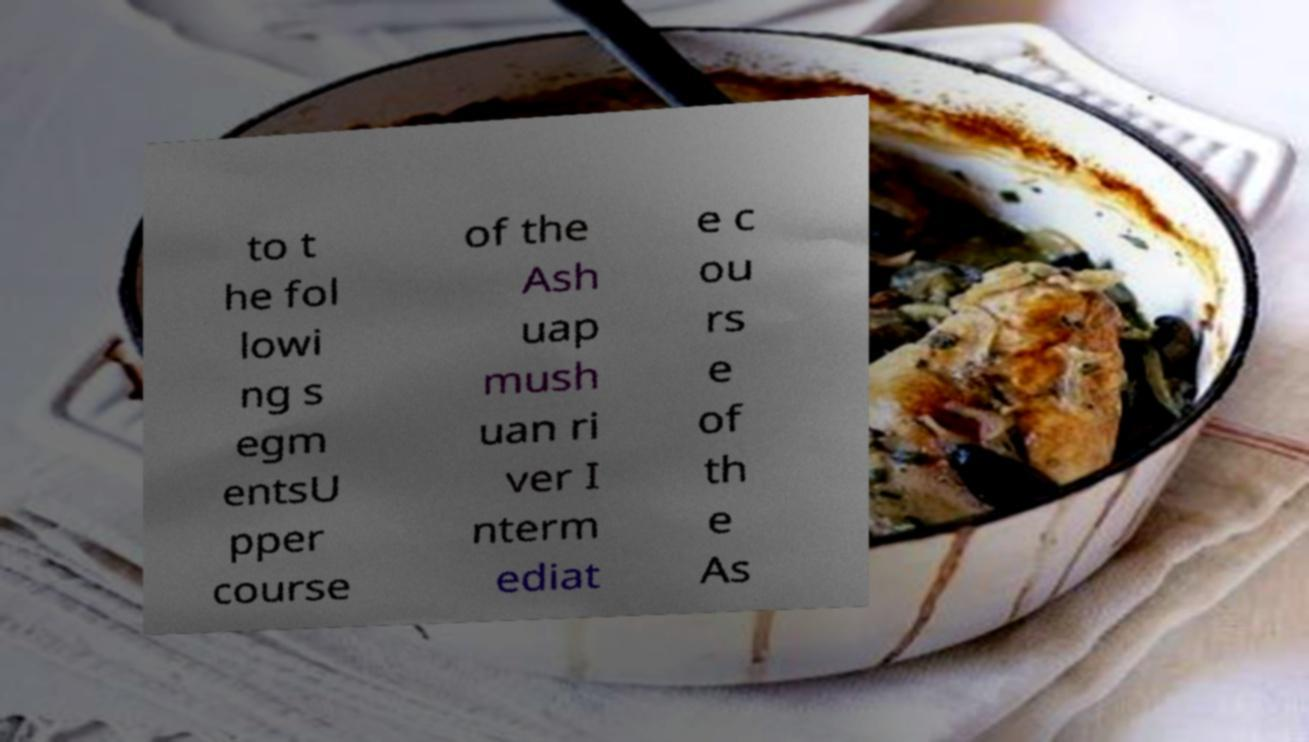Could you extract and type out the text from this image? to t he fol lowi ng s egm entsU pper course of the Ash uap mush uan ri ver I nterm ediat e c ou rs e of th e As 